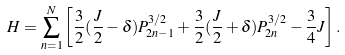Convert formula to latex. <formula><loc_0><loc_0><loc_500><loc_500>H = \sum _ { n = 1 } ^ { N } \left [ \frac { 3 } { 2 } ( \frac { J } { 2 } - \delta ) P _ { 2 n - 1 } ^ { 3 / 2 } + \frac { 3 } { 2 } ( \frac { J } { 2 } + \delta ) P _ { 2 n } ^ { 3 / 2 } - \frac { 3 } { 4 } J \right ] .</formula> 